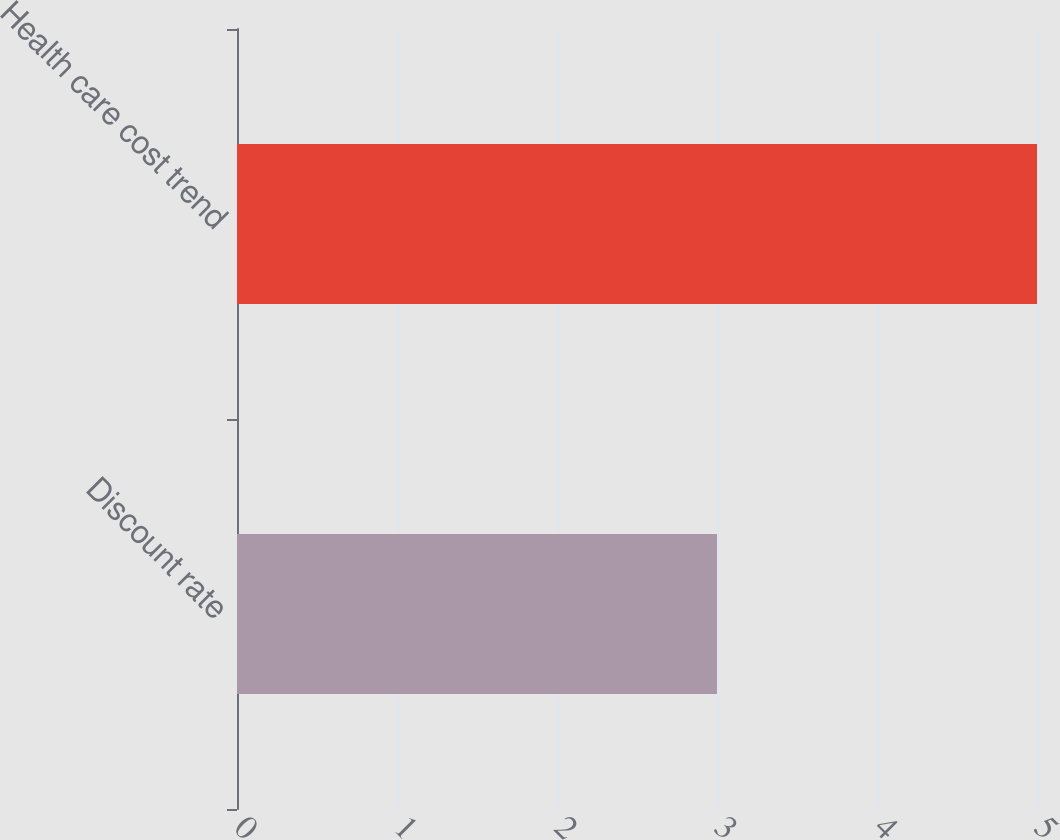Convert chart to OTSL. <chart><loc_0><loc_0><loc_500><loc_500><bar_chart><fcel>Discount rate<fcel>Health care cost trend<nl><fcel>3<fcel>5<nl></chart> 